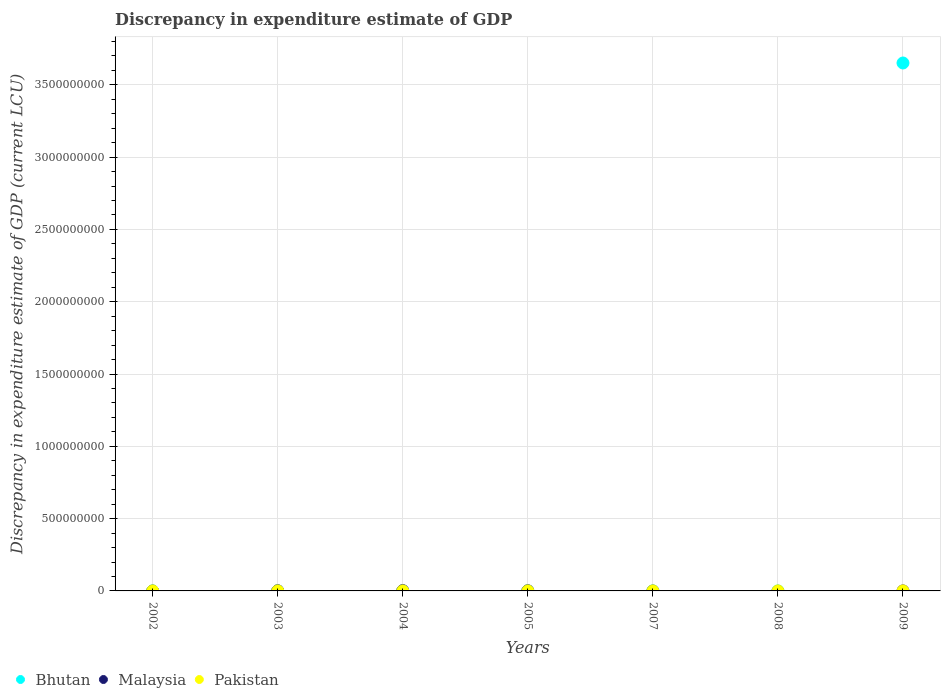Is the number of dotlines equal to the number of legend labels?
Your answer should be very brief. No. What is the discrepancy in expenditure estimate of GDP in Malaysia in 2008?
Ensure brevity in your answer.  0. Across all years, what is the maximum discrepancy in expenditure estimate of GDP in Malaysia?
Your response must be concise. 2.00e+06. Across all years, what is the minimum discrepancy in expenditure estimate of GDP in Pakistan?
Provide a succinct answer. 0. What is the total discrepancy in expenditure estimate of GDP in Pakistan in the graph?
Ensure brevity in your answer.  0. What is the difference between the discrepancy in expenditure estimate of GDP in Malaysia in 2008 and the discrepancy in expenditure estimate of GDP in Bhutan in 2007?
Provide a short and direct response. -4e-6. What is the average discrepancy in expenditure estimate of GDP in Malaysia per year?
Provide a succinct answer. 5.71e+05. In the year 2005, what is the difference between the discrepancy in expenditure estimate of GDP in Malaysia and discrepancy in expenditure estimate of GDP in Pakistan?
Keep it short and to the point. 1.00e+06. In how many years, is the discrepancy in expenditure estimate of GDP in Malaysia greater than 1100000000 LCU?
Provide a short and direct response. 0. Is the difference between the discrepancy in expenditure estimate of GDP in Malaysia in 2003 and 2005 greater than the difference between the discrepancy in expenditure estimate of GDP in Pakistan in 2003 and 2005?
Keep it short and to the point. Yes. What is the difference between the highest and the second highest discrepancy in expenditure estimate of GDP in Malaysia?
Your response must be concise. 1.00e+06. What is the difference between the highest and the lowest discrepancy in expenditure estimate of GDP in Bhutan?
Ensure brevity in your answer.  3.65e+09. Is it the case that in every year, the sum of the discrepancy in expenditure estimate of GDP in Pakistan and discrepancy in expenditure estimate of GDP in Bhutan  is greater than the discrepancy in expenditure estimate of GDP in Malaysia?
Give a very brief answer. No. Is the discrepancy in expenditure estimate of GDP in Pakistan strictly greater than the discrepancy in expenditure estimate of GDP in Bhutan over the years?
Offer a very short reply. No. Is the discrepancy in expenditure estimate of GDP in Malaysia strictly less than the discrepancy in expenditure estimate of GDP in Pakistan over the years?
Provide a succinct answer. No. What is the difference between two consecutive major ticks on the Y-axis?
Provide a short and direct response. 5.00e+08. Are the values on the major ticks of Y-axis written in scientific E-notation?
Provide a short and direct response. No. Does the graph contain grids?
Make the answer very short. Yes. How many legend labels are there?
Make the answer very short. 3. How are the legend labels stacked?
Provide a succinct answer. Horizontal. What is the title of the graph?
Offer a terse response. Discrepancy in expenditure estimate of GDP. What is the label or title of the X-axis?
Offer a very short reply. Years. What is the label or title of the Y-axis?
Provide a short and direct response. Discrepancy in expenditure estimate of GDP (current LCU). What is the Discrepancy in expenditure estimate of GDP (current LCU) in Pakistan in 2002?
Keep it short and to the point. 0. What is the Discrepancy in expenditure estimate of GDP (current LCU) in Bhutan in 2003?
Make the answer very short. 1e-6. What is the Discrepancy in expenditure estimate of GDP (current LCU) in Pakistan in 2003?
Ensure brevity in your answer.  0. What is the Discrepancy in expenditure estimate of GDP (current LCU) of Malaysia in 2004?
Make the answer very short. 2.00e+06. What is the Discrepancy in expenditure estimate of GDP (current LCU) in Pakistan in 2004?
Provide a succinct answer. 0. What is the Discrepancy in expenditure estimate of GDP (current LCU) in Bhutan in 2005?
Your answer should be very brief. 0. What is the Discrepancy in expenditure estimate of GDP (current LCU) of Malaysia in 2005?
Give a very brief answer. 1.00e+06. What is the Discrepancy in expenditure estimate of GDP (current LCU) of Pakistan in 2005?
Give a very brief answer. 0. What is the Discrepancy in expenditure estimate of GDP (current LCU) of Bhutan in 2007?
Provide a short and direct response. 4e-6. What is the Discrepancy in expenditure estimate of GDP (current LCU) in Malaysia in 2007?
Your answer should be very brief. 0. What is the Discrepancy in expenditure estimate of GDP (current LCU) of Pakistan in 2007?
Keep it short and to the point. 0. What is the Discrepancy in expenditure estimate of GDP (current LCU) of Bhutan in 2008?
Provide a short and direct response. 2e-6. What is the Discrepancy in expenditure estimate of GDP (current LCU) in Malaysia in 2008?
Offer a very short reply. 0. What is the Discrepancy in expenditure estimate of GDP (current LCU) of Bhutan in 2009?
Your answer should be compact. 3.65e+09. What is the Discrepancy in expenditure estimate of GDP (current LCU) of Pakistan in 2009?
Your response must be concise. 0. Across all years, what is the maximum Discrepancy in expenditure estimate of GDP (current LCU) in Bhutan?
Keep it short and to the point. 3.65e+09. Across all years, what is the maximum Discrepancy in expenditure estimate of GDP (current LCU) of Malaysia?
Ensure brevity in your answer.  2.00e+06. Across all years, what is the maximum Discrepancy in expenditure estimate of GDP (current LCU) of Pakistan?
Offer a very short reply. 0. Across all years, what is the minimum Discrepancy in expenditure estimate of GDP (current LCU) of Bhutan?
Your answer should be very brief. 0. What is the total Discrepancy in expenditure estimate of GDP (current LCU) in Bhutan in the graph?
Offer a very short reply. 3.65e+09. What is the total Discrepancy in expenditure estimate of GDP (current LCU) in Malaysia in the graph?
Your answer should be very brief. 4.00e+06. What is the difference between the Discrepancy in expenditure estimate of GDP (current LCU) of Malaysia in 2003 and that in 2004?
Give a very brief answer. -1.00e+06. What is the difference between the Discrepancy in expenditure estimate of GDP (current LCU) in Pakistan in 2003 and that in 2005?
Offer a very short reply. 0. What is the difference between the Discrepancy in expenditure estimate of GDP (current LCU) in Bhutan in 2003 and that in 2009?
Provide a short and direct response. -3.65e+09. What is the difference between the Discrepancy in expenditure estimate of GDP (current LCU) of Malaysia in 2004 and that in 2005?
Offer a very short reply. 1.00e+06. What is the difference between the Discrepancy in expenditure estimate of GDP (current LCU) in Pakistan in 2004 and that in 2005?
Give a very brief answer. 0. What is the difference between the Discrepancy in expenditure estimate of GDP (current LCU) in Bhutan in 2007 and that in 2009?
Ensure brevity in your answer.  -3.65e+09. What is the difference between the Discrepancy in expenditure estimate of GDP (current LCU) in Bhutan in 2008 and that in 2009?
Provide a short and direct response. -3.65e+09. What is the difference between the Discrepancy in expenditure estimate of GDP (current LCU) of Bhutan in 2003 and the Discrepancy in expenditure estimate of GDP (current LCU) of Pakistan in 2004?
Provide a short and direct response. -0. What is the difference between the Discrepancy in expenditure estimate of GDP (current LCU) in Malaysia in 2003 and the Discrepancy in expenditure estimate of GDP (current LCU) in Pakistan in 2004?
Keep it short and to the point. 1.00e+06. What is the difference between the Discrepancy in expenditure estimate of GDP (current LCU) of Bhutan in 2003 and the Discrepancy in expenditure estimate of GDP (current LCU) of Malaysia in 2005?
Give a very brief answer. -1.00e+06. What is the difference between the Discrepancy in expenditure estimate of GDP (current LCU) of Bhutan in 2003 and the Discrepancy in expenditure estimate of GDP (current LCU) of Pakistan in 2005?
Make the answer very short. -0. What is the difference between the Discrepancy in expenditure estimate of GDP (current LCU) in Malaysia in 2003 and the Discrepancy in expenditure estimate of GDP (current LCU) in Pakistan in 2005?
Offer a terse response. 1.00e+06. What is the difference between the Discrepancy in expenditure estimate of GDP (current LCU) of Malaysia in 2004 and the Discrepancy in expenditure estimate of GDP (current LCU) of Pakistan in 2005?
Ensure brevity in your answer.  2.00e+06. What is the average Discrepancy in expenditure estimate of GDP (current LCU) of Bhutan per year?
Give a very brief answer. 5.22e+08. What is the average Discrepancy in expenditure estimate of GDP (current LCU) in Malaysia per year?
Provide a succinct answer. 5.71e+05. In the year 2003, what is the difference between the Discrepancy in expenditure estimate of GDP (current LCU) in Bhutan and Discrepancy in expenditure estimate of GDP (current LCU) in Pakistan?
Your answer should be very brief. -0. In the year 2003, what is the difference between the Discrepancy in expenditure estimate of GDP (current LCU) of Malaysia and Discrepancy in expenditure estimate of GDP (current LCU) of Pakistan?
Offer a very short reply. 1.00e+06. In the year 2004, what is the difference between the Discrepancy in expenditure estimate of GDP (current LCU) in Malaysia and Discrepancy in expenditure estimate of GDP (current LCU) in Pakistan?
Your answer should be compact. 2.00e+06. In the year 2005, what is the difference between the Discrepancy in expenditure estimate of GDP (current LCU) of Malaysia and Discrepancy in expenditure estimate of GDP (current LCU) of Pakistan?
Your response must be concise. 1.00e+06. What is the ratio of the Discrepancy in expenditure estimate of GDP (current LCU) of Pakistan in 2003 to that in 2004?
Keep it short and to the point. 1. What is the ratio of the Discrepancy in expenditure estimate of GDP (current LCU) in Malaysia in 2003 to that in 2005?
Make the answer very short. 1. What is the ratio of the Discrepancy in expenditure estimate of GDP (current LCU) of Pakistan in 2003 to that in 2005?
Offer a very short reply. 1.2. What is the ratio of the Discrepancy in expenditure estimate of GDP (current LCU) in Bhutan in 2003 to that in 2007?
Keep it short and to the point. 0.25. What is the ratio of the Discrepancy in expenditure estimate of GDP (current LCU) of Bhutan in 2003 to that in 2008?
Keep it short and to the point. 0.5. What is the ratio of the Discrepancy in expenditure estimate of GDP (current LCU) in Bhutan in 2003 to that in 2009?
Offer a very short reply. 0. What is the ratio of the Discrepancy in expenditure estimate of GDP (current LCU) in Bhutan in 2007 to that in 2009?
Your answer should be very brief. 0. What is the ratio of the Discrepancy in expenditure estimate of GDP (current LCU) of Bhutan in 2008 to that in 2009?
Offer a very short reply. 0. What is the difference between the highest and the second highest Discrepancy in expenditure estimate of GDP (current LCU) of Bhutan?
Provide a succinct answer. 3.65e+09. What is the difference between the highest and the lowest Discrepancy in expenditure estimate of GDP (current LCU) in Bhutan?
Offer a very short reply. 3.65e+09. What is the difference between the highest and the lowest Discrepancy in expenditure estimate of GDP (current LCU) in Pakistan?
Your answer should be very brief. 0. 